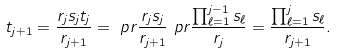Convert formula to latex. <formula><loc_0><loc_0><loc_500><loc_500>t _ { j + 1 } & = \frac { r _ { j } s _ { j } t _ { j } } { r _ { j + 1 } } = \ p r { \frac { r _ { j } s _ { j } } { r _ { j + 1 } } } \ p r { \frac { \prod _ { \ell = 1 } ^ { j - 1 } s _ { \ell } } { r _ { j } } } = \frac { \prod _ { \ell = 1 } ^ { j } s _ { \ell } } { r _ { j + 1 } } .</formula> 